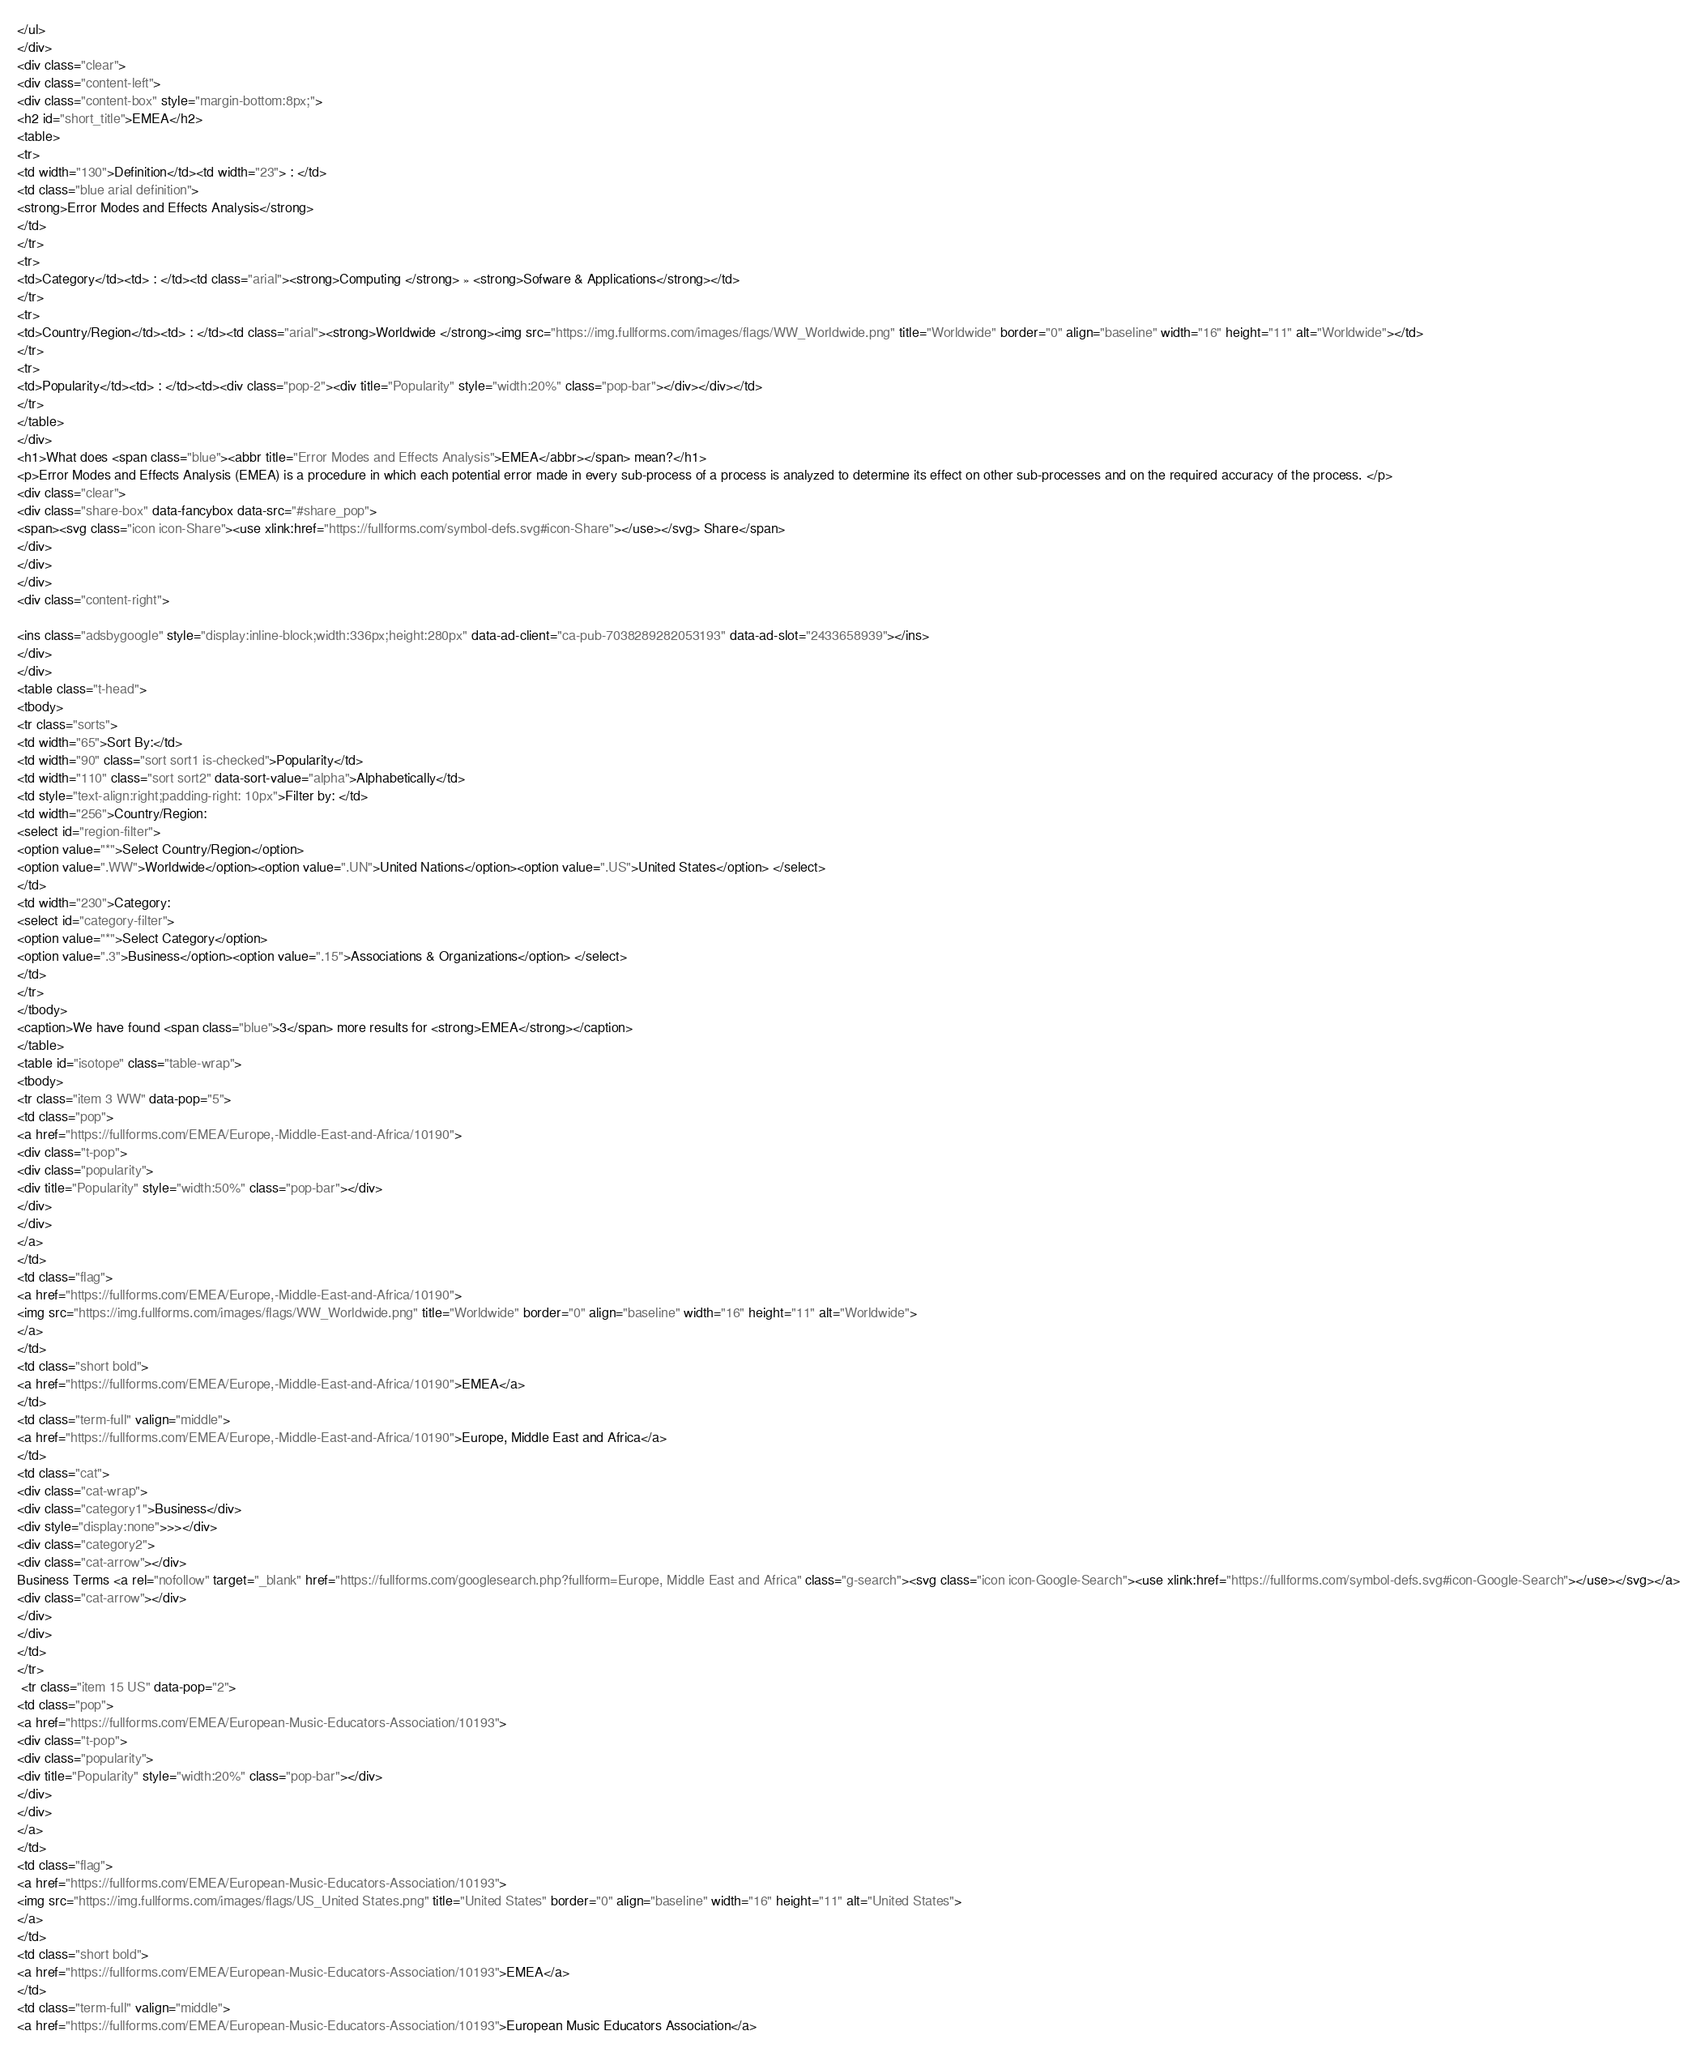Convert code to text. <code><loc_0><loc_0><loc_500><loc_500><_HTML_></ul>
</div>
<div class="clear">
<div class="content-left">
<div class="content-box" style="margin-bottom:8px;">
<h2 id="short_title">EMEA</h2>
<table>
<tr>
<td width="130">Definition</td><td width="23"> : </td>
<td class="blue arial definition">
<strong>Error Modes and Effects Analysis</strong>
</td>
</tr>
<tr>
<td>Category</td><td> : </td><td class="arial"><strong>Computing </strong> » <strong>Sofware & Applications</strong></td>
</tr>
<tr>
<td>Country/Region</td><td> : </td><td class="arial"><strong>Worldwide </strong><img src="https://img.fullforms.com/images/flags/WW_Worldwide.png" title="Worldwide" border="0" align="baseline" width="16" height="11" alt="Worldwide"></td>
</tr>
<tr>
<td>Popularity</td><td> : </td><td><div class="pop-2"><div title="Popularity" style="width:20%" class="pop-bar"></div></div></td>
</tr>
</table>
</div>
<h1>What does <span class="blue"><abbr title="Error Modes and Effects Analysis">EMEA</abbr></span> mean?</h1>
<p>Error Modes and Effects Analysis (EMEA) is a procedure in which each potential error made in every sub-process of a process is analyzed to determine its effect on other sub-processes and on the required accuracy of the process. </p>
<div class="clear">
<div class="share-box" data-fancybox data-src="#share_pop">
<span><svg class="icon icon-Share"><use xlink:href="https://fullforms.com/symbol-defs.svg#icon-Share"></use></svg> Share</span>
</div>
</div>
</div>
<div class="content-right">

<ins class="adsbygoogle" style="display:inline-block;width:336px;height:280px" data-ad-client="ca-pub-7038289282053193" data-ad-slot="2433658939"></ins>
</div>
</div>
<table class="t-head">
<tbody>
<tr class="sorts">
<td width="65">Sort By:</td>
<td width="90" class="sort sort1 is-checked">Popularity</td>
<td width="110" class="sort sort2" data-sort-value="alpha">Alphabetically</td>
<td style="text-align:right;padding-right: 10px">Filter by: </td>
<td width="256">Country/Region:
<select id="region-filter">
<option value="*">Select Country/Region</option>
<option value=".WW">Worldwide</option><option value=".UN">United Nations</option><option value=".US">United States</option> </select>
</td>
<td width="230">Category:
<select id="category-filter">
<option value="*">Select Category</option>
<option value=".3">Business</option><option value=".15">Associations & Organizations</option> </select>
</td>
</tr>
</tbody>
<caption>We have found <span class="blue">3</span> more results for <strong>EMEA</strong></caption>
</table>
<table id="isotope" class="table-wrap">
<tbody>
<tr class="item 3 WW" data-pop="5">
<td class="pop">
<a href="https://fullforms.com/EMEA/Europe,-Middle-East-and-Africa/10190">
<div class="t-pop">
<div class="popularity">
<div title="Popularity" style="width:50%" class="pop-bar"></div>
</div>
</div>
</a>
</td>
<td class="flag">
<a href="https://fullforms.com/EMEA/Europe,-Middle-East-and-Africa/10190">
<img src="https://img.fullforms.com/images/flags/WW_Worldwide.png" title="Worldwide" border="0" align="baseline" width="16" height="11" alt="Worldwide">
</a>
</td>
<td class="short bold">
<a href="https://fullforms.com/EMEA/Europe,-Middle-East-and-Africa/10190">EMEA</a>
</td>
<td class="term-full" valign="middle">
<a href="https://fullforms.com/EMEA/Europe,-Middle-East-and-Africa/10190">Europe, Middle East and Africa</a>
</td>
<td class="cat">
<div class="cat-wrap">
<div class="category1">Business</div>
<div style="display:none">>></div>
<div class="category2">
<div class="cat-arrow"></div>
Business Terms <a rel="nofollow" target="_blank" href="https://fullforms.com/googlesearch.php?fullform=Europe, Middle East and Africa" class="g-search"><svg class="icon icon-Google-Search"><use xlink:href="https://fullforms.com/symbol-defs.svg#icon-Google-Search"></use></svg></a>
<div class="cat-arrow"></div>
</div>
</div>
</td>
</tr>
 <tr class="item 15 US" data-pop="2">
<td class="pop">
<a href="https://fullforms.com/EMEA/European-Music-Educators-Association/10193">
<div class="t-pop">
<div class="popularity">
<div title="Popularity" style="width:20%" class="pop-bar"></div>
</div>
</div>
</a>
</td>
<td class="flag">
<a href="https://fullforms.com/EMEA/European-Music-Educators-Association/10193">
<img src="https://img.fullforms.com/images/flags/US_United States.png" title="United States" border="0" align="baseline" width="16" height="11" alt="United States">
</a>
</td>
<td class="short bold">
<a href="https://fullforms.com/EMEA/European-Music-Educators-Association/10193">EMEA</a>
</td>
<td class="term-full" valign="middle">
<a href="https://fullforms.com/EMEA/European-Music-Educators-Association/10193">European Music Educators Association</a></code> 